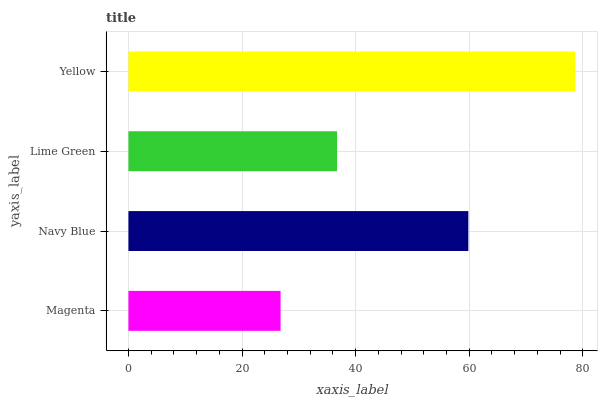Is Magenta the minimum?
Answer yes or no. Yes. Is Yellow the maximum?
Answer yes or no. Yes. Is Navy Blue the minimum?
Answer yes or no. No. Is Navy Blue the maximum?
Answer yes or no. No. Is Navy Blue greater than Magenta?
Answer yes or no. Yes. Is Magenta less than Navy Blue?
Answer yes or no. Yes. Is Magenta greater than Navy Blue?
Answer yes or no. No. Is Navy Blue less than Magenta?
Answer yes or no. No. Is Navy Blue the high median?
Answer yes or no. Yes. Is Lime Green the low median?
Answer yes or no. Yes. Is Magenta the high median?
Answer yes or no. No. Is Navy Blue the low median?
Answer yes or no. No. 